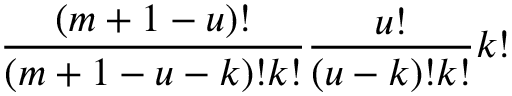<formula> <loc_0><loc_0><loc_500><loc_500>\frac { ( m + 1 - u ) ! } { ( m + 1 - u - k ) ! k ! } \frac { u ! } { ( u - k ) ! k ! } k !</formula> 